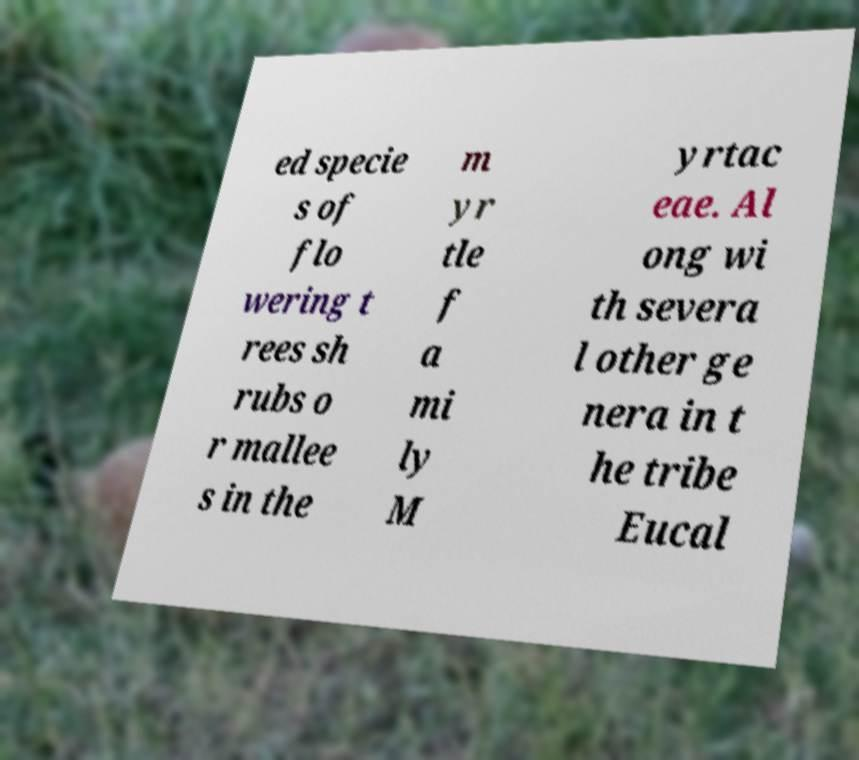Please identify and transcribe the text found in this image. ed specie s of flo wering t rees sh rubs o r mallee s in the m yr tle f a mi ly M yrtac eae. Al ong wi th severa l other ge nera in t he tribe Eucal 